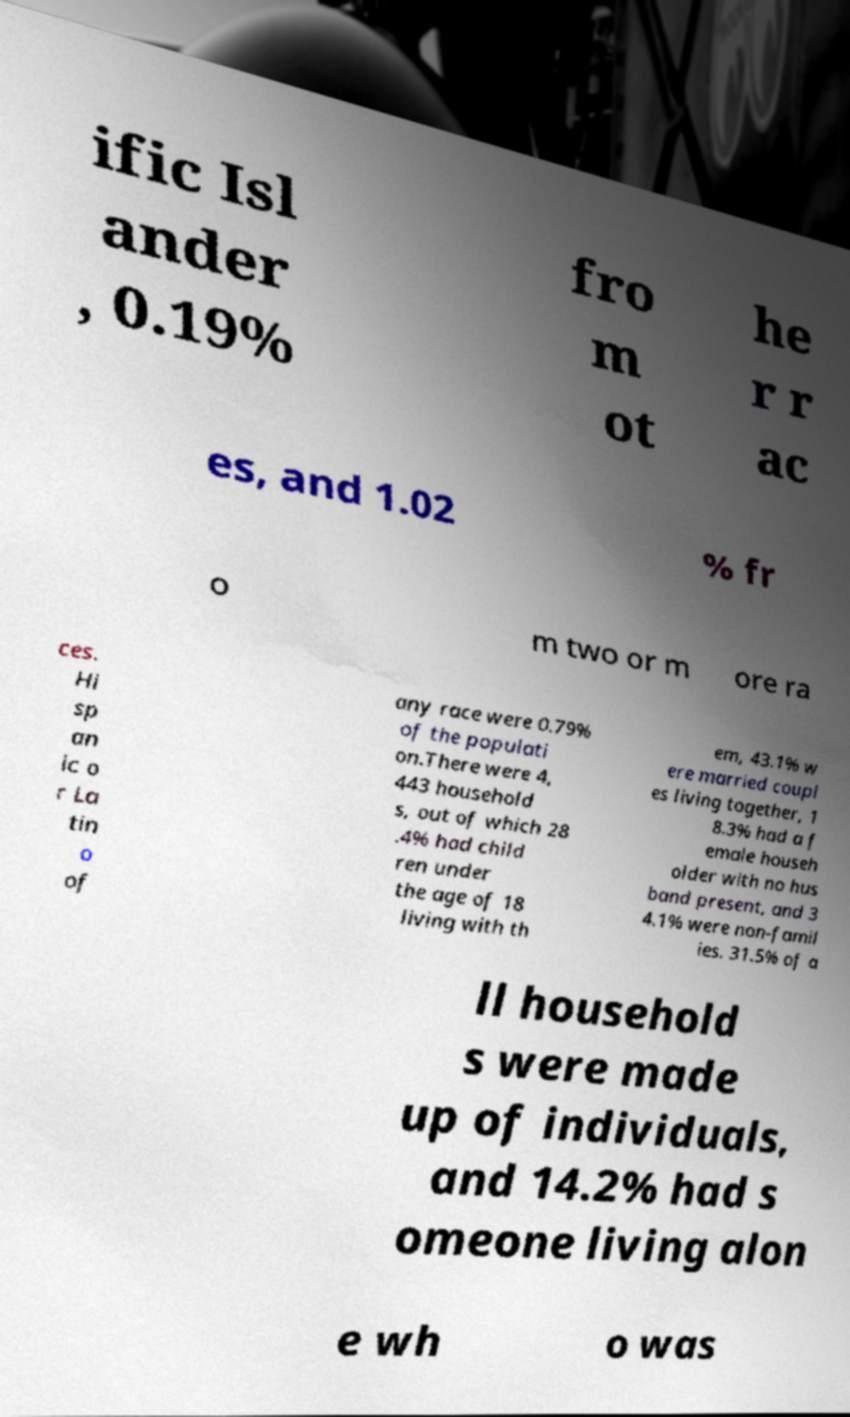I need the written content from this picture converted into text. Can you do that? ific Isl ander , 0.19% fro m ot he r r ac es, and 1.02 % fr o m two or m ore ra ces. Hi sp an ic o r La tin o of any race were 0.79% of the populati on.There were 4, 443 household s, out of which 28 .4% had child ren under the age of 18 living with th em, 43.1% w ere married coupl es living together, 1 8.3% had a f emale househ older with no hus band present, and 3 4.1% were non-famil ies. 31.5% of a ll household s were made up of individuals, and 14.2% had s omeone living alon e wh o was 